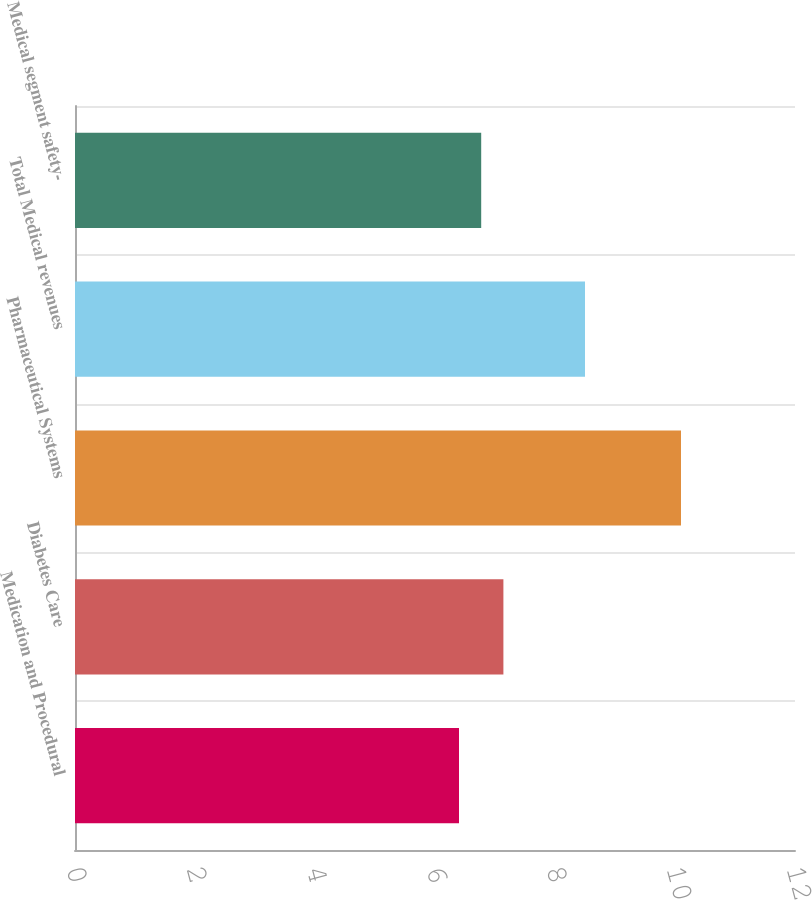<chart> <loc_0><loc_0><loc_500><loc_500><bar_chart><fcel>Medication and Procedural<fcel>Diabetes Care<fcel>Pharmaceutical Systems<fcel>Total Medical revenues<fcel>Medical segment safety-<nl><fcel>6.4<fcel>7.14<fcel>10.1<fcel>8.5<fcel>6.77<nl></chart> 